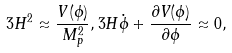Convert formula to latex. <formula><loc_0><loc_0><loc_500><loc_500>3 H ^ { 2 } \approx \frac { V ( \phi ) } { M _ { p } ^ { 2 } } , 3 H \dot { \phi } + \frac { \partial V ( \phi ) } { \partial \phi } \approx 0 ,</formula> 